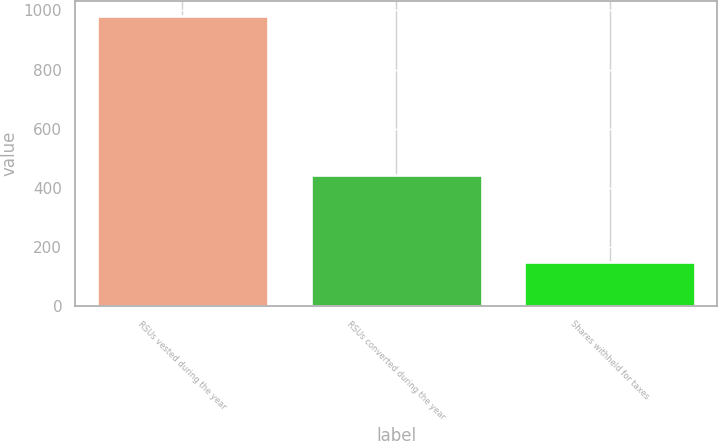Convert chart to OTSL. <chart><loc_0><loc_0><loc_500><loc_500><bar_chart><fcel>RSUs vested during the year<fcel>RSUs converted during the year<fcel>Shares withheld for taxes<nl><fcel>982<fcel>442<fcel>150<nl></chart> 